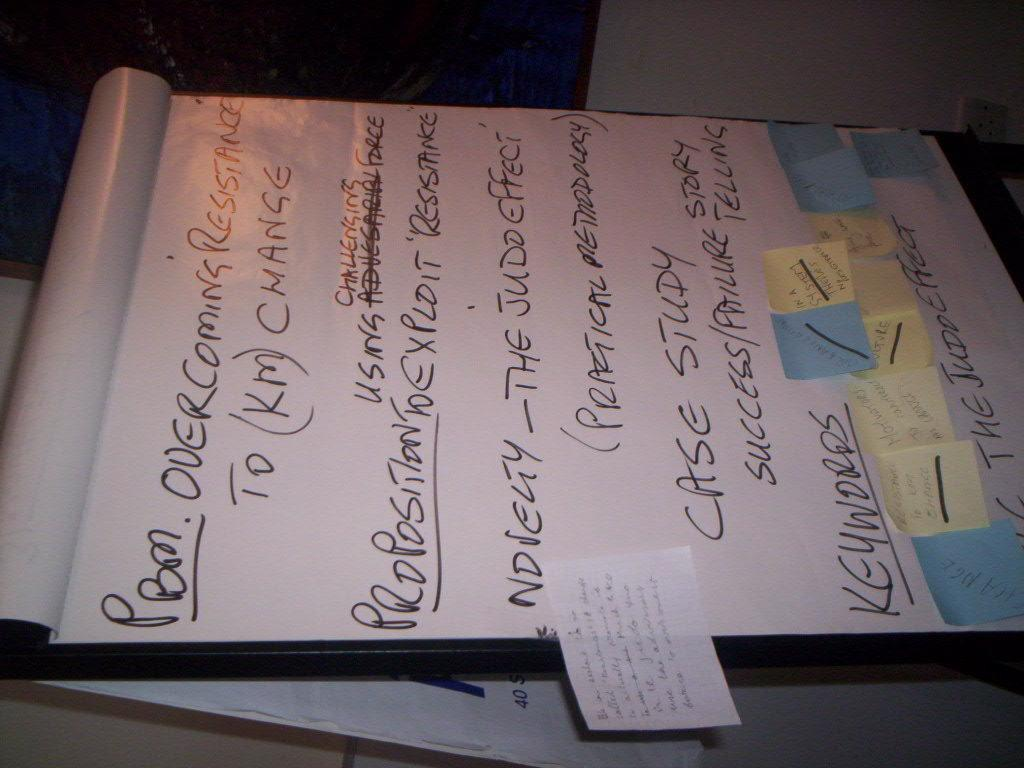<image>
Give a short and clear explanation of the subsequent image. Some ideas about overcoming resistance are written on a large sheet. 